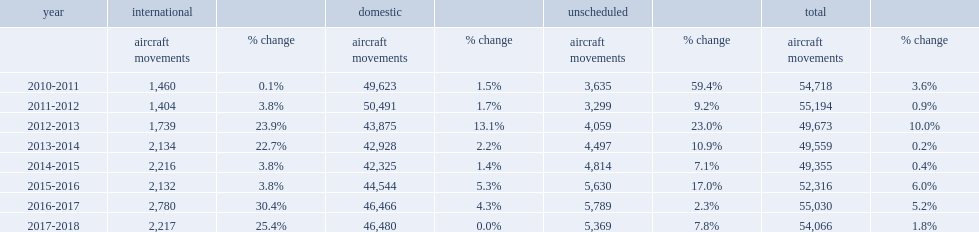Parse the table in full. {'header': ['year', 'international', '', 'domestic', '', 'unscheduled', '', 'total', ''], 'rows': [['', 'aircraft movements', '% change', 'aircraft movements', '% change', 'aircraft movements', '% change', 'aircraft movements', '% change'], ['2010-2011', '1,460', '0.1%', '49,623', '1.5%', '3,635', '59.4%', '54,718', '3.6%'], ['2011-2012', '1,404', '3.8%', '50,491', '1.7%', '3,299', '9.2%', '55,194', '0.9%'], ['2012-2013', '1,739', '23.9%', '43,875', '13.1%', '4,059', '23.0%', '49,673', '10.0%'], ['2013-2014', '2,134', '22.7%', '42,928', '2.2%', '4,497', '10.9%', '49,559', '0.2%'], ['2014-2015', '2,216', '3.8%', '42,325', '1.4%', '4,814', '7.1%', '49,355', '0.4%'], ['2015-2016', '2,132', '3.8%', '44,544', '5.3%', '5,630', '17.0%', '52,316', '6.0%'], ['2016-2017', '2,780', '30.4%', '46,466', '4.3%', '5,789', '2.3%', '55,030', '5.2%'], ['2017-2018', '2,217', '25.4%', '46,480', '0.0%', '5,369', '7.8%', '54,066', '1.8%']]} What was the total number of aircraft traffic movements recorded in 2017-2018? 54066.0. 